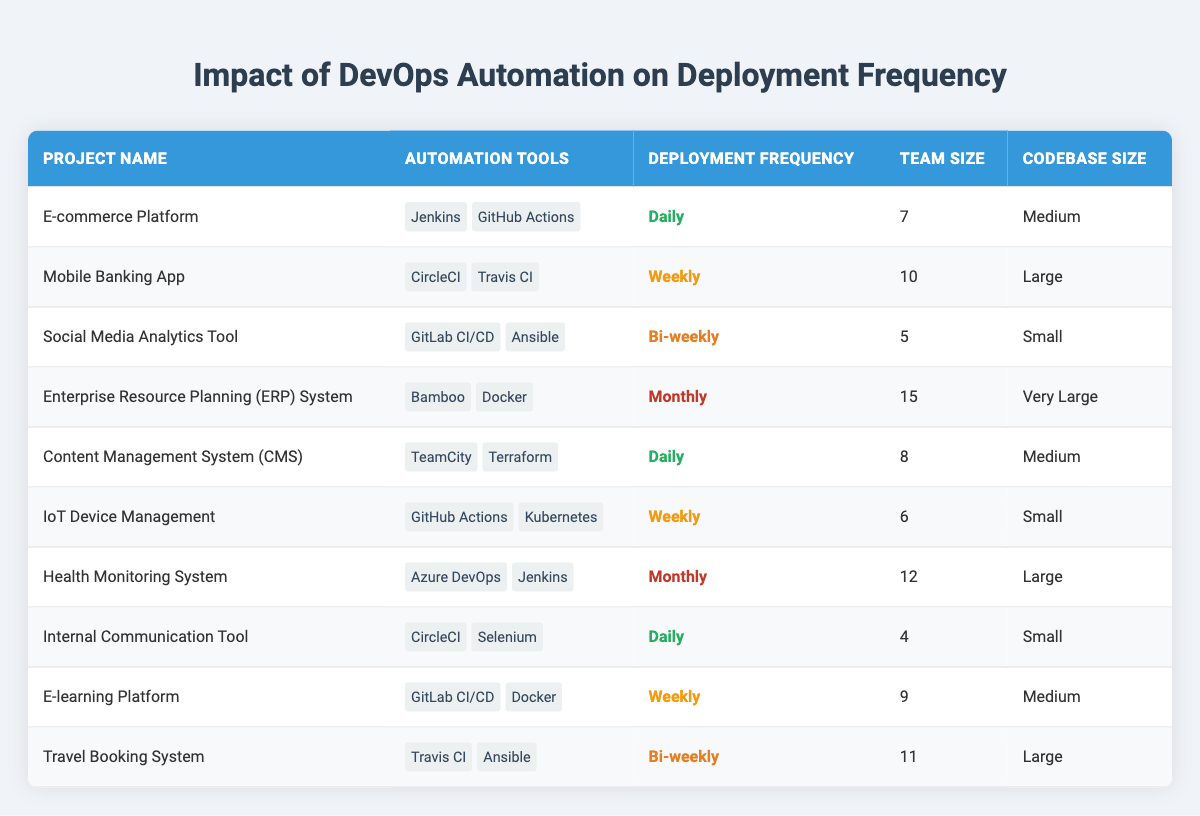What is the deployment frequency of the "E-commerce Platform"? The "E-commerce Platform" is listed in the table, and its deployment frequency is stated clearly as "Daily."
Answer: Daily Which project has the largest team size? To find the largest team size, I compare the team sizes of all projects. The "Enterprise Resource Planning (ERP) System" has the largest team size of 15 members.
Answer: 15 How many projects have "Daily" deployment frequency? By reviewing the table, I count the projects with "Daily" deployment frequency: "E-commerce Platform," "Content Management System (CMS)," and "Internal Communication Tool." There are 3 such projects.
Answer: 3 Are there any projects that use both GitHub Actions and Jenkins? I look through the automation tools for each project. The "E-commerce Platform" uses "GitHub Actions," and the "Health Monitoring System" uses "Jenkins," but there are no projects that use both tools simultaneously.
Answer: No What is the average team size of projects that have a "Weekly" deployment frequency? The projects with a "Weekly" deployment frequency are "Mobile Banking App" (team size 10), "IoT Device Management" (team size 6), and "E-learning Platform" (team size 9). I calculate the average by summing these sizes: (10 + 6 + 9) = 25, then divide by the number of projects (3), which gives 25/3 = 8.33.
Answer: 8.33 Which codebase size is most frequently associated with projects that have "Monthly" deployment frequency? I check the codebase sizes for projects with "Monthly" deployment frequency. The projects are "Enterprise Resource Planning (ERP) System" (Very Large) and "Health Monitoring System" (Large). There are no codebase sizes repeated for "Monthly," but the most common size present is "Large."
Answer: Large How many projects use automation tools that include Docker? I review the automation tools and find that "Enterprise Resource Planning (ERP) System" and "E-learning Platform" both use Docker. Hence, there are 2 projects with Docker as one of their automation tools.
Answer: 2 Is the "Social Media Analytics Tool" deployed more frequently than the "Health Monitoring System"? The "Social Media Analytics Tool" has a deployment frequency of "Bi-weekly," while the "Health Monitoring System" has a deployment frequency of "Monthly." Since "Bi-weekly" is more frequent than "Monthly," the answer is yes.
Answer: Yes What is the total number of projects with "Small" codebase size? I examine the codebase sizes and locate the projects with "Small" codebase size: "Social Media Analytics Tool," "IoT Device Management," and "Internal Communication Tool." Thus, there are 3 projects in this category.
Answer: 3 